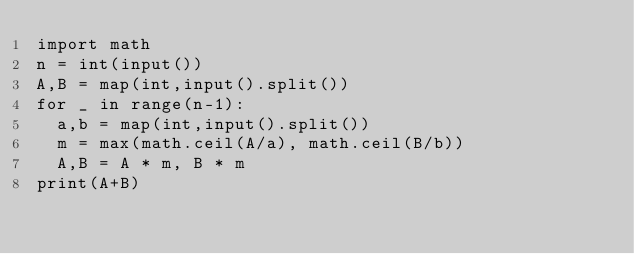Convert code to text. <code><loc_0><loc_0><loc_500><loc_500><_Python_>import math
n = int(input())
A,B = map(int,input().split())
for _ in range(n-1):
  a,b = map(int,input().split())
  m = max(math.ceil(A/a), math.ceil(B/b))
  A,B = A * m, B * m
print(A+B)</code> 